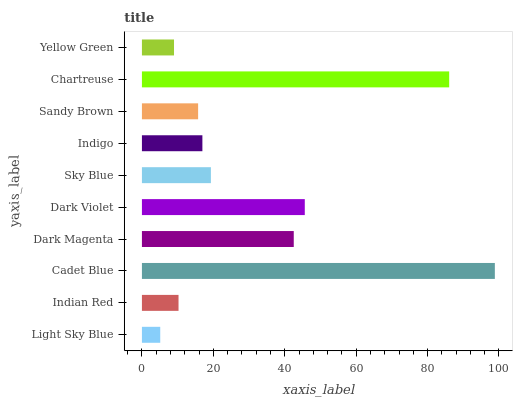Is Light Sky Blue the minimum?
Answer yes or no. Yes. Is Cadet Blue the maximum?
Answer yes or no. Yes. Is Indian Red the minimum?
Answer yes or no. No. Is Indian Red the maximum?
Answer yes or no. No. Is Indian Red greater than Light Sky Blue?
Answer yes or no. Yes. Is Light Sky Blue less than Indian Red?
Answer yes or no. Yes. Is Light Sky Blue greater than Indian Red?
Answer yes or no. No. Is Indian Red less than Light Sky Blue?
Answer yes or no. No. Is Sky Blue the high median?
Answer yes or no. Yes. Is Indigo the low median?
Answer yes or no. Yes. Is Chartreuse the high median?
Answer yes or no. No. Is Light Sky Blue the low median?
Answer yes or no. No. 